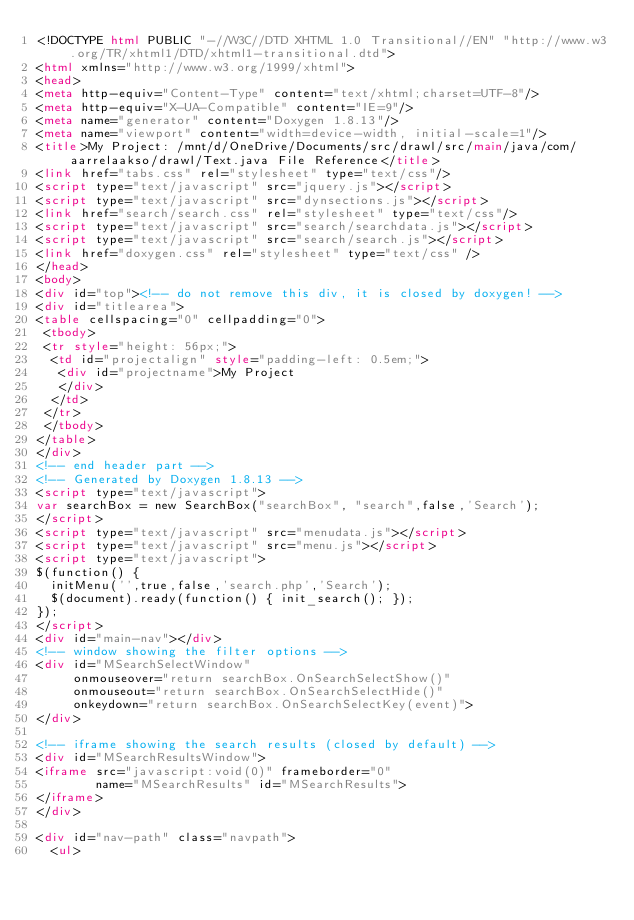Convert code to text. <code><loc_0><loc_0><loc_500><loc_500><_HTML_><!DOCTYPE html PUBLIC "-//W3C//DTD XHTML 1.0 Transitional//EN" "http://www.w3.org/TR/xhtml1/DTD/xhtml1-transitional.dtd">
<html xmlns="http://www.w3.org/1999/xhtml">
<head>
<meta http-equiv="Content-Type" content="text/xhtml;charset=UTF-8"/>
<meta http-equiv="X-UA-Compatible" content="IE=9"/>
<meta name="generator" content="Doxygen 1.8.13"/>
<meta name="viewport" content="width=device-width, initial-scale=1"/>
<title>My Project: /mnt/d/OneDrive/Documents/src/drawl/src/main/java/com/aarrelaakso/drawl/Text.java File Reference</title>
<link href="tabs.css" rel="stylesheet" type="text/css"/>
<script type="text/javascript" src="jquery.js"></script>
<script type="text/javascript" src="dynsections.js"></script>
<link href="search/search.css" rel="stylesheet" type="text/css"/>
<script type="text/javascript" src="search/searchdata.js"></script>
<script type="text/javascript" src="search/search.js"></script>
<link href="doxygen.css" rel="stylesheet" type="text/css" />
</head>
<body>
<div id="top"><!-- do not remove this div, it is closed by doxygen! -->
<div id="titlearea">
<table cellspacing="0" cellpadding="0">
 <tbody>
 <tr style="height: 56px;">
  <td id="projectalign" style="padding-left: 0.5em;">
   <div id="projectname">My Project
   </div>
  </td>
 </tr>
 </tbody>
</table>
</div>
<!-- end header part -->
<!-- Generated by Doxygen 1.8.13 -->
<script type="text/javascript">
var searchBox = new SearchBox("searchBox", "search",false,'Search');
</script>
<script type="text/javascript" src="menudata.js"></script>
<script type="text/javascript" src="menu.js"></script>
<script type="text/javascript">
$(function() {
  initMenu('',true,false,'search.php','Search');
  $(document).ready(function() { init_search(); });
});
</script>
<div id="main-nav"></div>
<!-- window showing the filter options -->
<div id="MSearchSelectWindow"
     onmouseover="return searchBox.OnSearchSelectShow()"
     onmouseout="return searchBox.OnSearchSelectHide()"
     onkeydown="return searchBox.OnSearchSelectKey(event)">
</div>

<!-- iframe showing the search results (closed by default) -->
<div id="MSearchResultsWindow">
<iframe src="javascript:void(0)" frameborder="0" 
        name="MSearchResults" id="MSearchResults">
</iframe>
</div>

<div id="nav-path" class="navpath">
  <ul></code> 